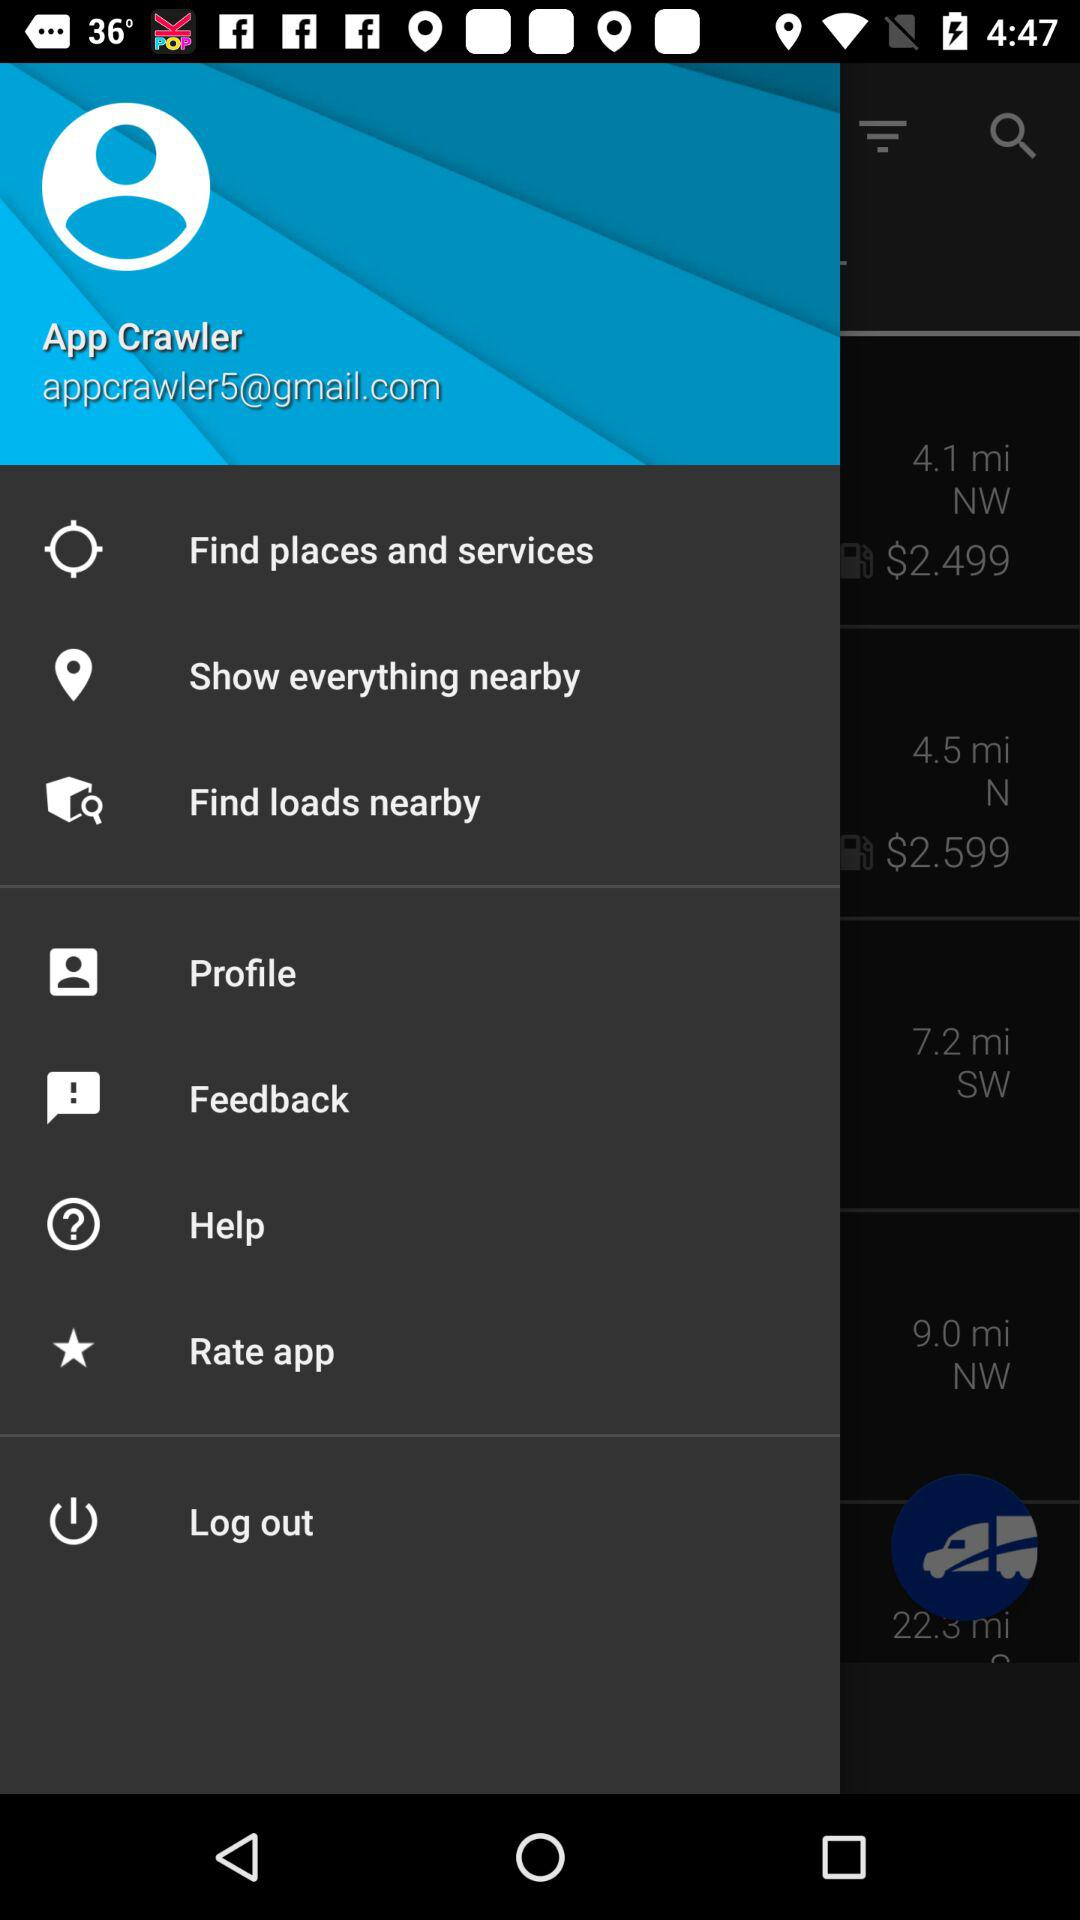What is the user email ID? The user email ID is appcrawler5@gmail.com. 